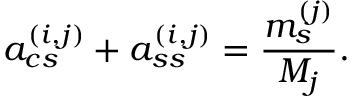Convert formula to latex. <formula><loc_0><loc_0><loc_500><loc_500>a _ { c s } ^ { ( i , j ) } + a _ { s s } ^ { ( i , j ) } = \frac { m _ { s } ^ { ( j ) } } { M _ { j } } .</formula> 